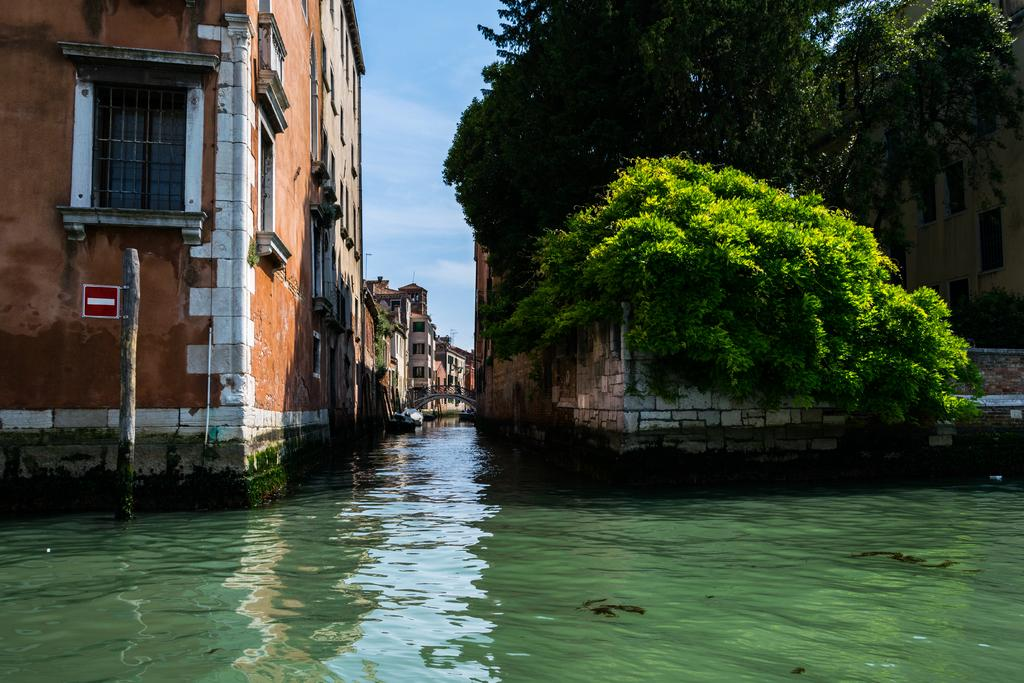What is the primary element present in the image? There is water in the image. What type of structures can be seen in the image? There are buildings in the image. What feature of the buildings is visible in the image? There are windows visible in the image. What type of vegetation is present in the image? There are trees in the image. What is visible at the top of the image? The sky is visible at the top of the image. What type of writing can be seen on the brake in the image? There is no brake present in the image, and therefore no writing can be observed on it. 